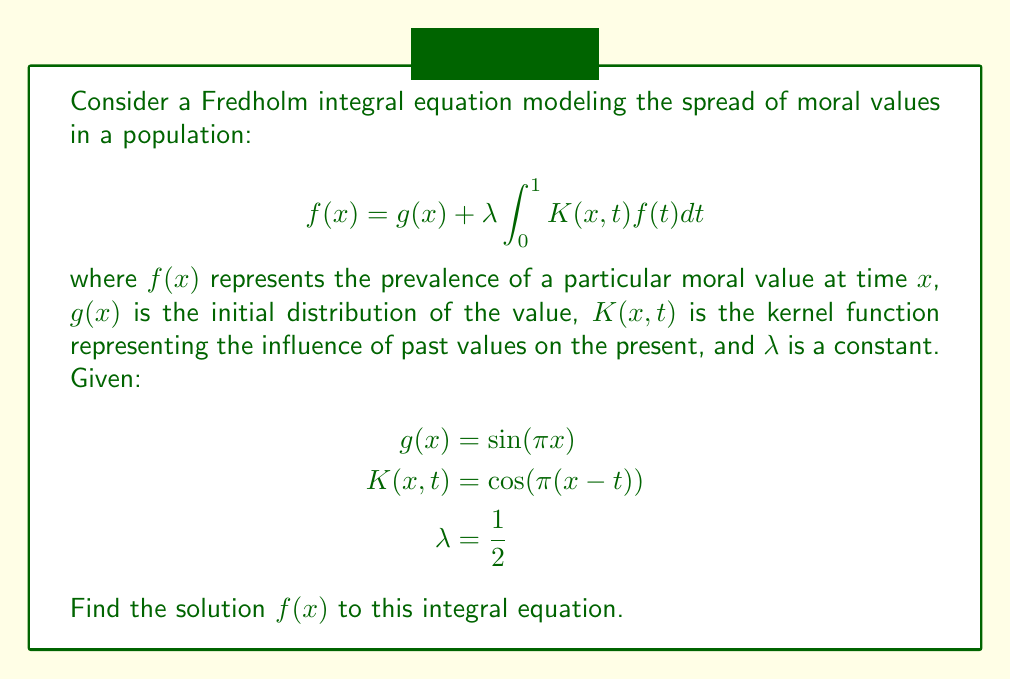Can you answer this question? To solve this Fredholm integral equation, we'll follow these steps:

1) First, we assume a solution of the form:
   $$f(x) = A \sin(\pi x)$$
   where $A$ is a constant to be determined.

2) Substitute this into the original equation:
   $$A \sin(\pi x) = \sin(\pi x) + \frac{1}{2} \int_0^1 \cos(\pi(x-t)) \cdot A \sin(\pi t)dt$$

3) Simplify the right-hand side:
   $$A \sin(\pi x) = \sin(\pi x) + \frac{A}{2} \int_0^1 [\cos(\pi x)\cos(\pi t) + \sin(\pi x)\sin(\pi t)] \sin(\pi t)dt$$

4) Evaluate the integrals:
   $$\int_0^1 \cos(\pi t)\sin(\pi t)dt = 0$$
   $$\int_0^1 \sin^2(\pi t)dt = \frac{1}{2}$$

5) Simplify:
   $$A \sin(\pi x) = \sin(\pi x) + \frac{A}{2} \sin(\pi x) \cdot \frac{1}{2}$$

6) Factor out $\sin(\pi x)$:
   $$A \sin(\pi x) = \sin(\pi x) + \frac{A}{4} \sin(\pi x)$$

7) Equate coefficients:
   $$A = 1 + \frac{A}{4}$$

8) Solve for $A$:
   $$\frac{3A}{4} = 1$$
   $$A = \frac{4}{3}$$

9) Therefore, the solution is:
   $$f(x) = \frac{4}{3} \sin(\pi x)$$

This solution represents the equilibrium distribution of the moral value in the population over time, taking into account the initial distribution and the influence of past values on the present.
Answer: $f(x) = \frac{4}{3} \sin(\pi x)$ 